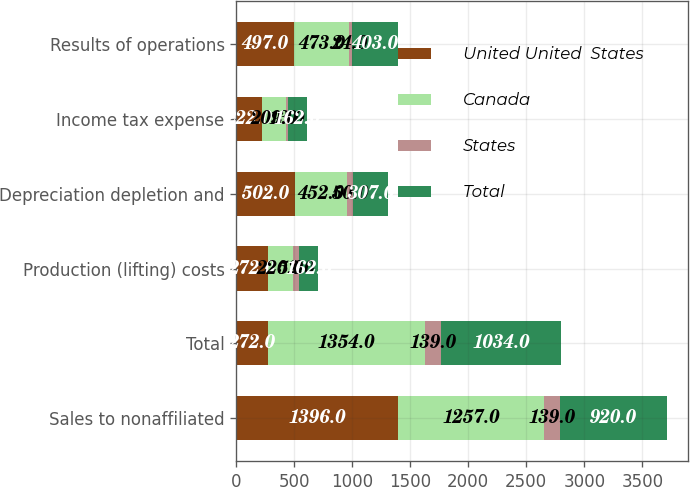<chart> <loc_0><loc_0><loc_500><loc_500><stacked_bar_chart><ecel><fcel>Sales to nonaffiliated<fcel>Total<fcel>Production (lifting) costs<fcel>Depreciation depletion and<fcel>Income tax expense<fcel>Results of operations<nl><fcel>United United  States<fcel>1396<fcel>272<fcel>272<fcel>502<fcel>222<fcel>497<nl><fcel>Canada<fcel>1257<fcel>1354<fcel>220<fcel>452<fcel>209<fcel>473<nl><fcel>States<fcel>139<fcel>139<fcel>52<fcel>50<fcel>13<fcel>24<nl><fcel>Total<fcel>920<fcel>1034<fcel>162<fcel>307<fcel>162<fcel>403<nl></chart> 